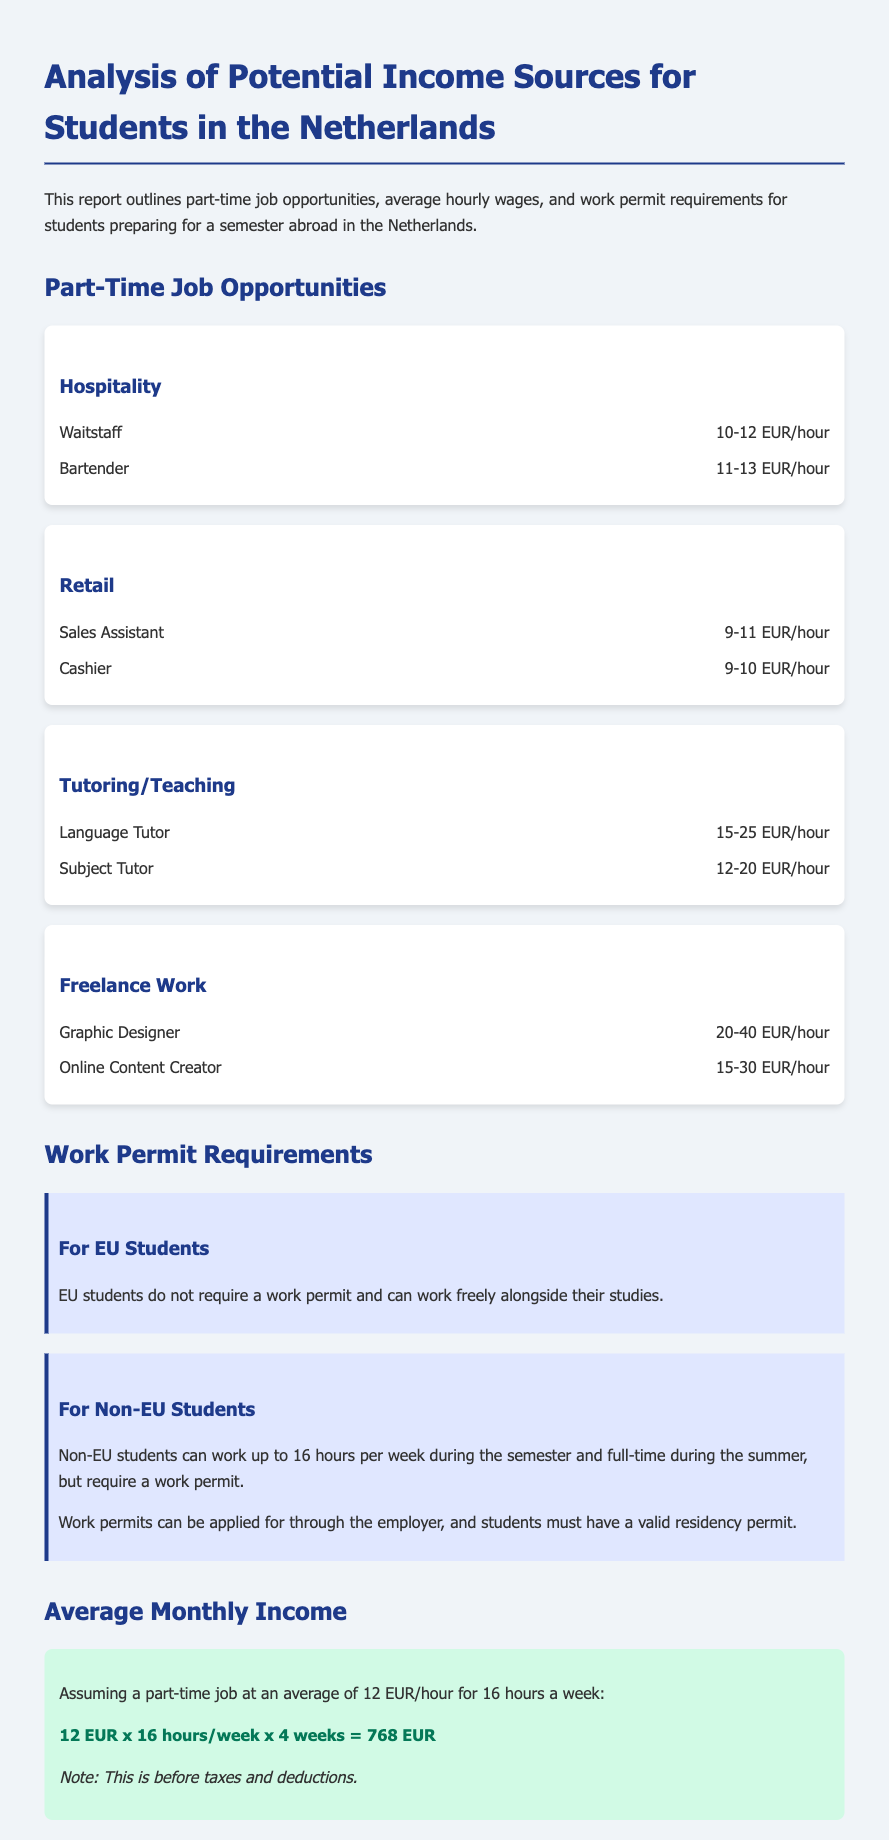what is the hourly wage range for waitstaff? The document lists the hourly wage range for waitstaff in the hospitality section as 10-12 EUR/hour.
Answer: 10-12 EUR/hour how much can a language tutor earn hourly? According to the tutoring/teaching section, a language tutor can earn 15-25 EUR/hour.
Answer: 15-25 EUR/hour what is the maximum number of hours Non-EU students can work during the semester? The document states that Non-EU students can work up to 16 hours per week during the semester.
Answer: 16 hours what is the average monthly income for a part-time job at 12 EUR/hour working 16 hours a week? The average monthly income is calculated as 12 EUR x 16 hours/week x 4 weeks, resulting in 768 EUR.
Answer: 768 EUR do EU students need a work permit? The document mentions that EU students do not require a work permit.
Answer: No what job category offers an income range from 9-11 EUR/hour? The retail job category offers an income range for sales assistants as 9-11 EUR/hour.
Answer: Retail which type of freelance work has the highest earning potential? The document lists graphic designers in freelance work with an hourly wage range of 20-40 EUR/hour, indicating the highest earning potential.
Answer: Graphic Designer who is responsible for applying for work permits for Non-EU students? The document states that work permits can be applied for through the employer.
Answer: Employer 